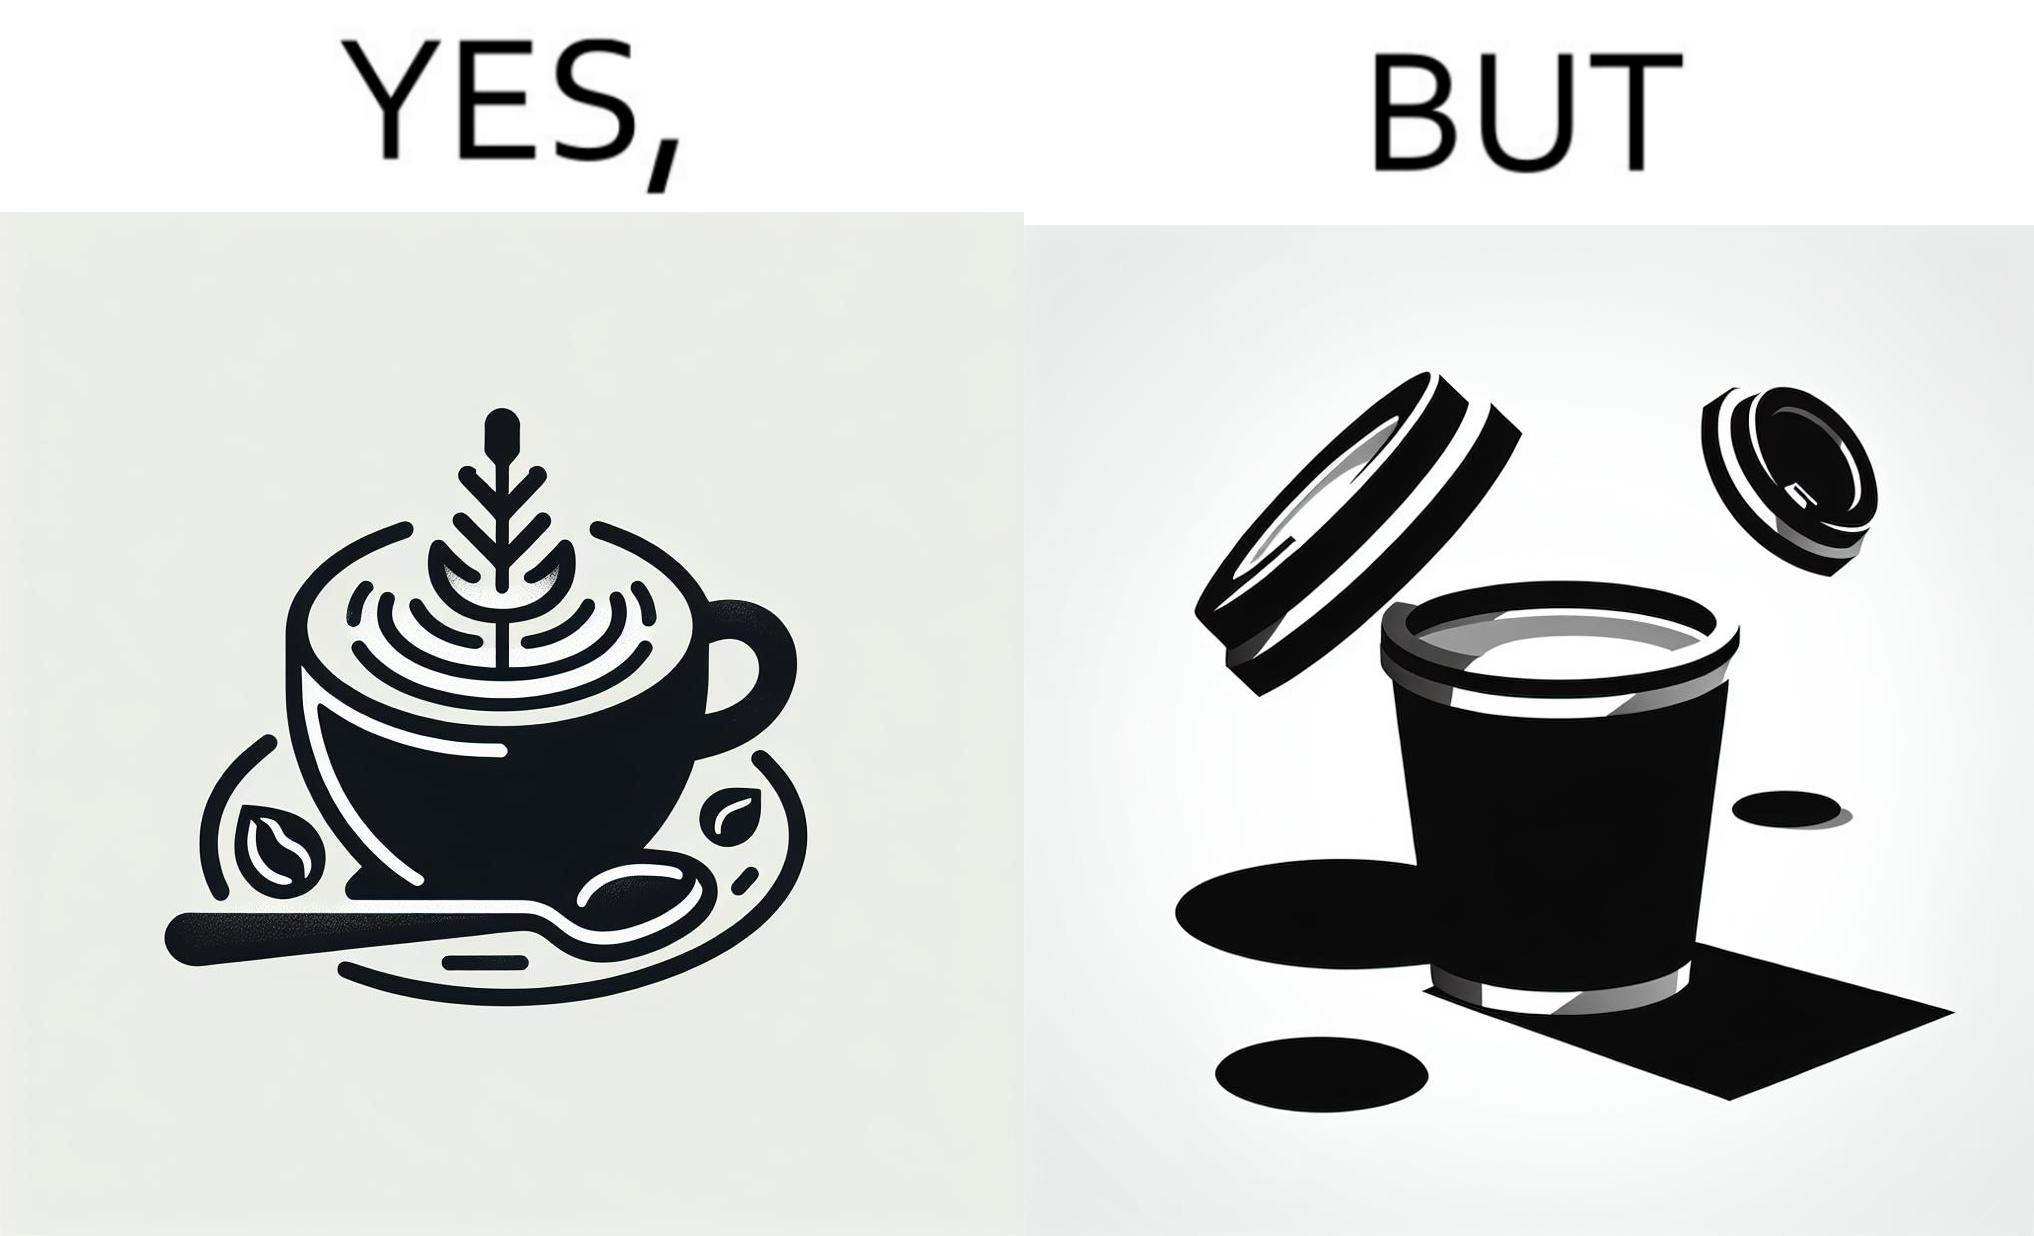What do you see in each half of this image? In the left part of the image: It is a cup of coffee with latte art In the right part of the image: It is a cup of coffee with its lid on top 